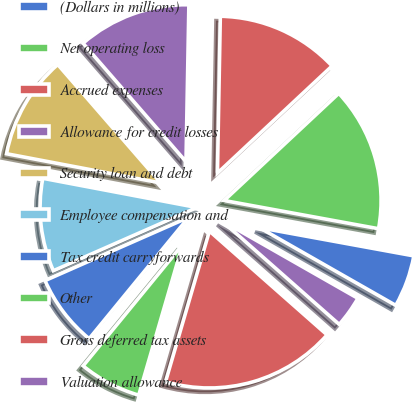Convert chart. <chart><loc_0><loc_0><loc_500><loc_500><pie_chart><fcel>(Dollars in millions)<fcel>Net operating loss<fcel>Accrued expenses<fcel>Allowance for credit losses<fcel>Security loan and debt<fcel>Employee compensation and<fcel>Tax credit carryforwards<fcel>Other<fcel>Gross deferred tax assets<fcel>Valuation allowance<nl><fcel>5.37%<fcel>14.84%<fcel>12.74%<fcel>11.68%<fcel>10.63%<fcel>9.58%<fcel>7.47%<fcel>6.42%<fcel>18.0%<fcel>3.26%<nl></chart> 